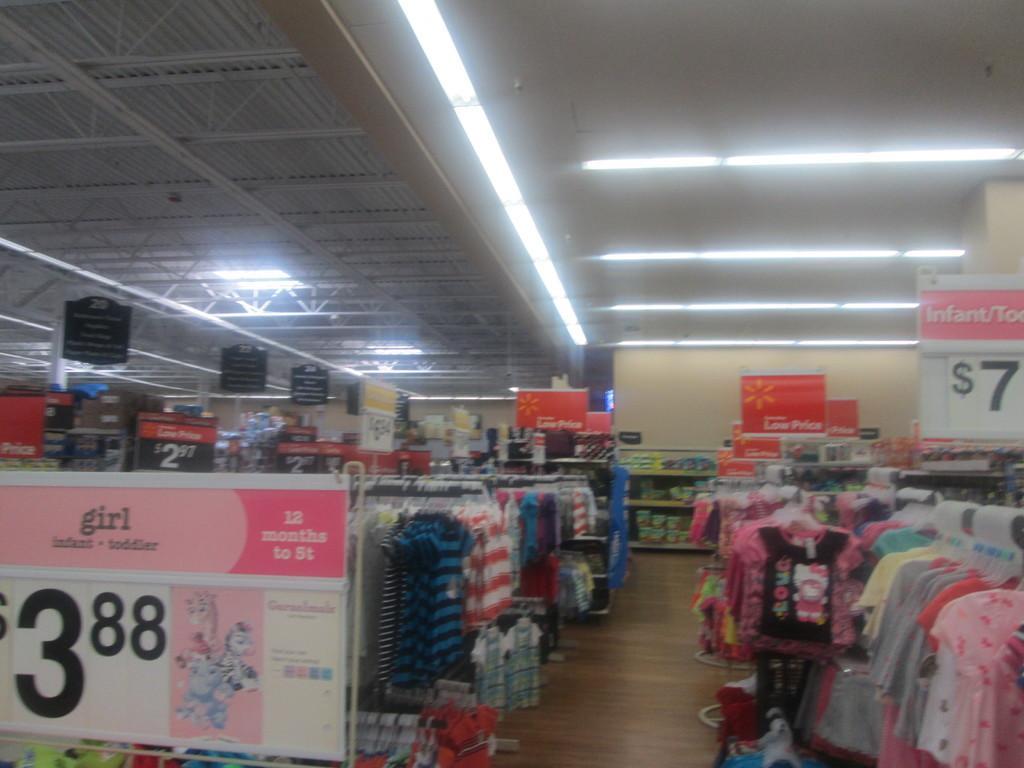How would you summarize this image in a sentence or two? In this picture I can see the inside view of the mall. At the bottom I can see many different kind of dresses were hanging on this pole. In the bottom left there is a poster which showing the price of the cloth. In the back I can see some boxes on the wooden racks. At the top I can see many tube lights on the wall and shed. 